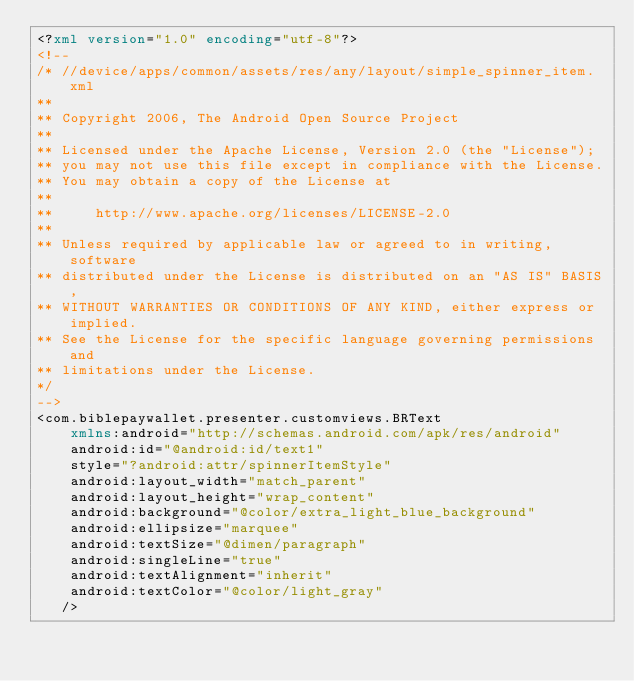Convert code to text. <code><loc_0><loc_0><loc_500><loc_500><_XML_><?xml version="1.0" encoding="utf-8"?>
<!--
/* //device/apps/common/assets/res/any/layout/simple_spinner_item.xml
**
** Copyright 2006, The Android Open Source Project
**
** Licensed under the Apache License, Version 2.0 (the "License");
** you may not use this file except in compliance with the License.
** You may obtain a copy of the License at
**
**     http://www.apache.org/licenses/LICENSE-2.0
**
** Unless required by applicable law or agreed to in writing, software
** distributed under the License is distributed on an "AS IS" BASIS,
** WITHOUT WARRANTIES OR CONDITIONS OF ANY KIND, either express or implied.
** See the License for the specific language governing permissions and
** limitations under the License.
*/
-->
<com.biblepaywallet.presenter.customviews.BRText
    xmlns:android="http://schemas.android.com/apk/res/android"
    android:id="@android:id/text1"
    style="?android:attr/spinnerItemStyle"
    android:layout_width="match_parent"
    android:layout_height="wrap_content"
    android:background="@color/extra_light_blue_background"
    android:ellipsize="marquee"
    android:textSize="@dimen/paragraph"
    android:singleLine="true"
    android:textAlignment="inherit"
    android:textColor="@color/light_gray"
   />
</code> 